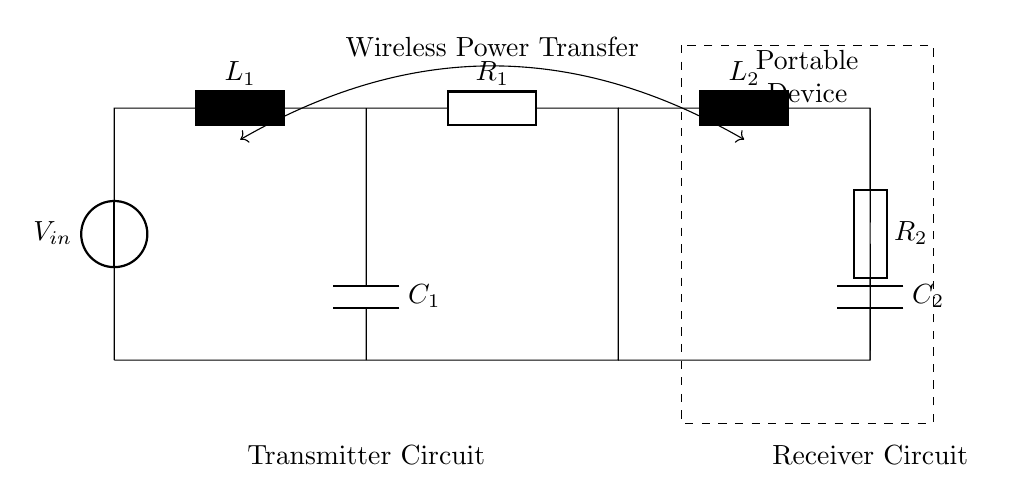What type of circuit is depicted in this diagram? The circuit is a resonant RLC circuit, which includes resistors, inductors, and capacitors for wireless power transfer applications.
Answer: Resonant RLC circuit What are the components labeled in the transmitter circuit? The transmitter circuit includes a voltage source, an inductor labeled L1, and a resistor labeled R1 connected in series, along with a capacitor labeled C1 connected to ground.
Answer: Voltage source, inductor L1, resistor R1, capacitor C1 What is the function of the capacitors in this circuit? The capacitors C1 and C2 store electrical energy and are crucial for tuning the circuit to resonate at a specific frequency for effective power transfer.
Answer: Energy storage and tuning How many inductors are in the circuit? There are two inductors present in the circuit, labeled L1 and L2, which are essential for magnetic coupling between the transmitter and receiver circuits.
Answer: Two What is the relationship indicated by the double-headed arrow between the transmitter and receiver circuits? The double-headed arrow signifies wireless power transfer, indicating that the circuit is designed to transmit energy wirelessly from the transmitter to the receiver.
Answer: Wireless Power Transfer What happens to the frequency at resonance in an RLC circuit? At resonance, the inductive reactance and capacitive reactance are equal, allowing maximum current to flow, which is critical for efficient power transfer in wireless applications.
Answer: Maximum current flow What is the significance of the resistors R1 and R2 in this circuit? Resistors R1 and R2 provide damping in the circuit which can affect the bandwidth and stability of the resonant frequency, ensuring the circuit operates efficiently and preventing excessive oscillations.
Answer: Damping and stability 